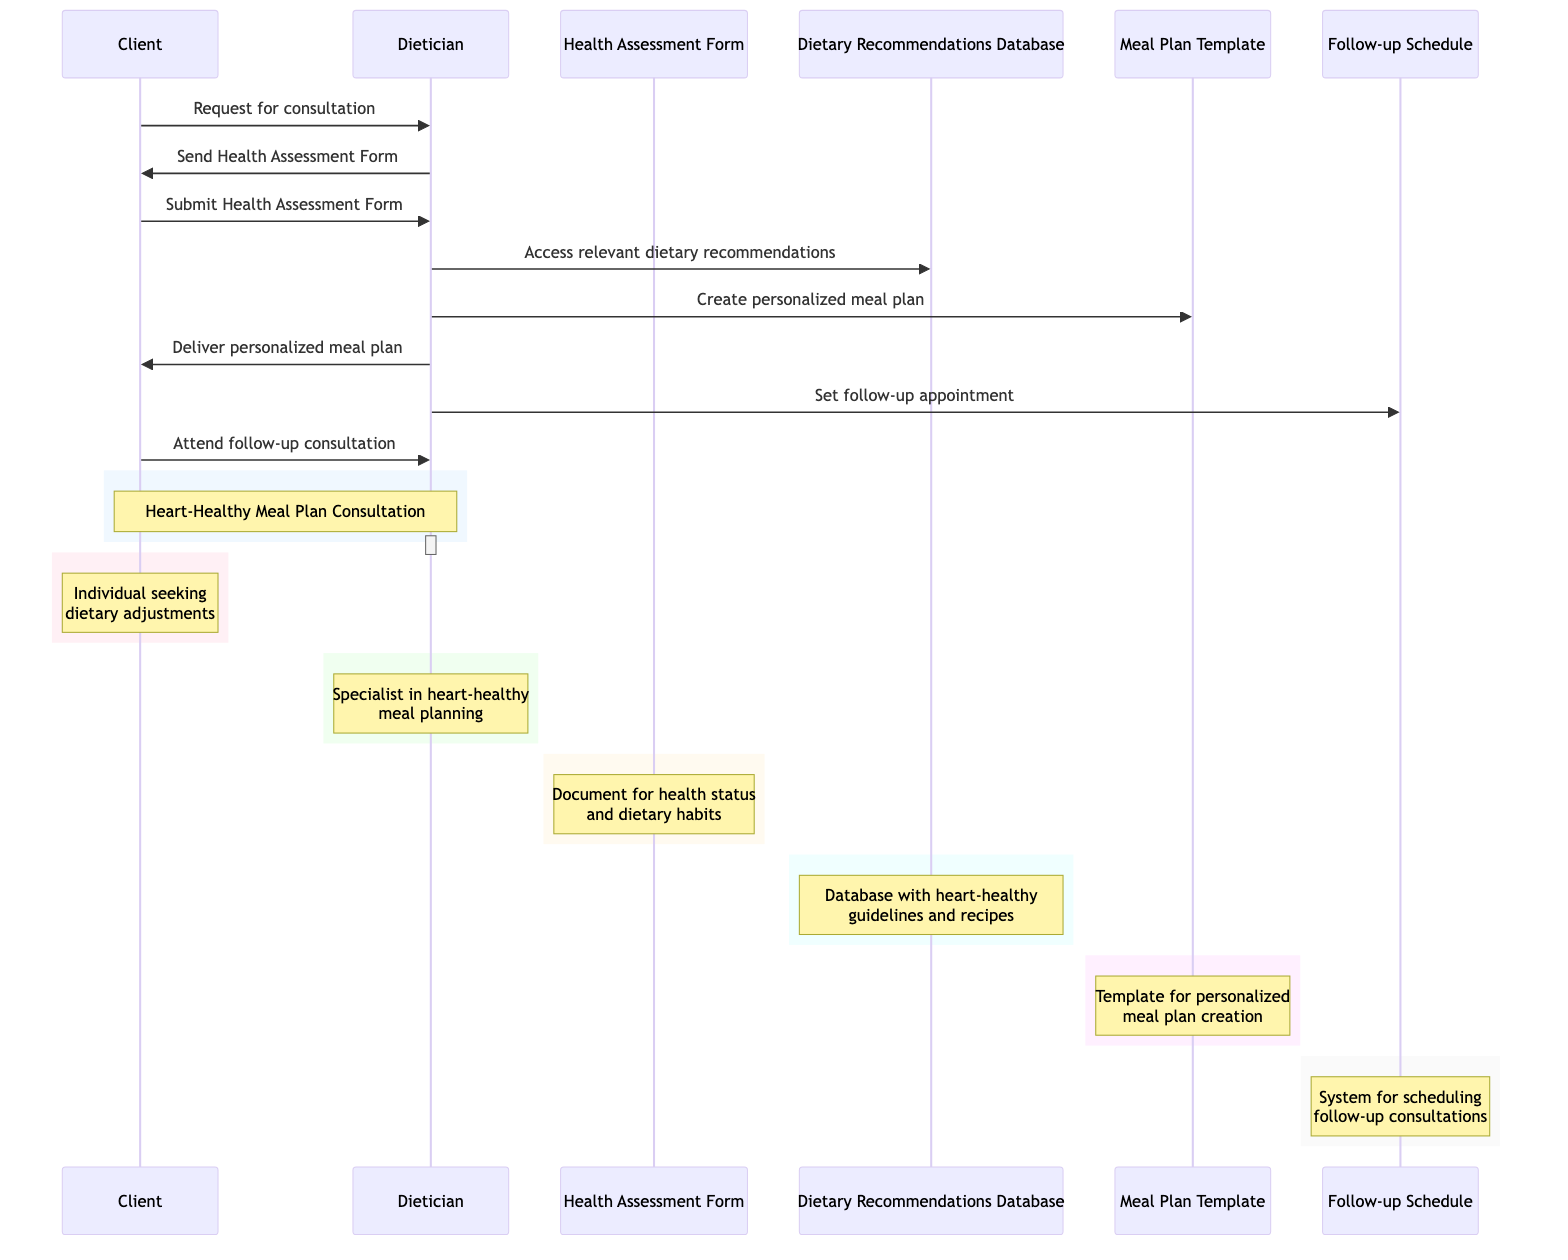What is the first action taken by the Client? The diagram shows that the first action initiated by the Client is to request a consultation from the Dietician. This is represented in the first arrow from Client to Dietician.
Answer: Request for consultation How many documents are involved in the consultation process? In the diagram, there are two documents represented: the Health Assessment Form and the Meal Plan Template. Counting them gives us a total of two documents.
Answer: 2 What system does the Dietician use to access dietary recommendations? The diagram indicates that the Dietician accesses the Dietary Recommendations Database to retrieve the necessary dietary guidelines. This is depicted by the arrow from Dietician to the Dietary Recommendations Database.
Answer: Dietary Recommendations Database Which actor delivers the personalized meal plan? According to the diagram, the Dietician is responsible for delivering the personalized meal plan to the Client. This is shown in the interaction where the Dietician sends the meal plan to the Client.
Answer: Dietician What action occurs after the Client submits the Health Assessment Form? The sequence shows that after the Client submits the Health Assessment Form, the Dietician accesses relevant dietary recommendations from the Dietary Recommendations Database. This indicates the next step in the process.
Answer: Access relevant dietary recommendations What is the purpose of the Follow-up Schedule system? The Follow-up Schedule system is used by the Dietician to set a follow-up appointment to review the client's progress. This function is specified in the diagram just after delivering the meal plan.
Answer: Schedule follow-up appointments Which entity is used to create the personalized meal plan? The Dietician utilizes the Meal Plan Template to create the personalized meal plan for the Client. This action is depicted by the interaction from the Dietician to the Meal Plan Template.
Answer: Meal Plan Template How many interactions are initiated by the Client? The diagram illustrates that the Client initiates three interactions: requesting a consultation, submitting the Health Assessment Form, and attending the follow-up consultation. This totals to three interactions.
Answer: 3 What occurs last in the sequence of actions? The final action in the sequence is the Client attending the follow-up consultation. This is represented by the last arrow going from Client to Dietician in the diagram.
Answer: Attend follow-up consultation 